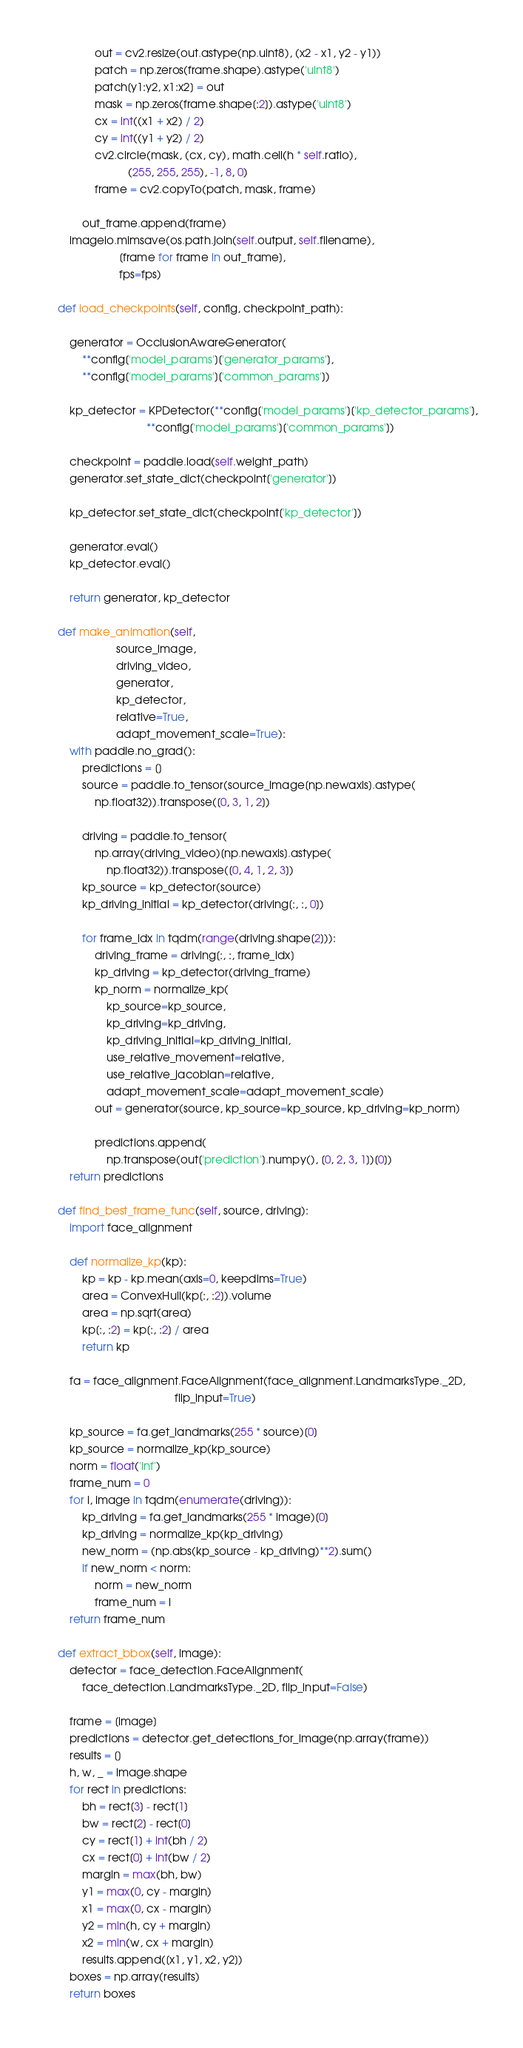Convert code to text. <code><loc_0><loc_0><loc_500><loc_500><_Python_>                out = cv2.resize(out.astype(np.uint8), (x2 - x1, y2 - y1))
                patch = np.zeros(frame.shape).astype('uint8')
                patch[y1:y2, x1:x2] = out
                mask = np.zeros(frame.shape[:2]).astype('uint8')
                cx = int((x1 + x2) / 2)
                cy = int((y1 + y2) / 2)
                cv2.circle(mask, (cx, cy), math.ceil(h * self.ratio),
                           (255, 255, 255), -1, 8, 0)
                frame = cv2.copyTo(patch, mask, frame)

            out_frame.append(frame)
        imageio.mimsave(os.path.join(self.output, self.filename),
                        [frame for frame in out_frame],
                        fps=fps)

    def load_checkpoints(self, config, checkpoint_path):

        generator = OcclusionAwareGenerator(
            **config['model_params']['generator_params'],
            **config['model_params']['common_params'])

        kp_detector = KPDetector(**config['model_params']['kp_detector_params'],
                                 **config['model_params']['common_params'])

        checkpoint = paddle.load(self.weight_path)
        generator.set_state_dict(checkpoint['generator'])

        kp_detector.set_state_dict(checkpoint['kp_detector'])

        generator.eval()
        kp_detector.eval()

        return generator, kp_detector

    def make_animation(self,
                       source_image,
                       driving_video,
                       generator,
                       kp_detector,
                       relative=True,
                       adapt_movement_scale=True):
        with paddle.no_grad():
            predictions = []
            source = paddle.to_tensor(source_image[np.newaxis].astype(
                np.float32)).transpose([0, 3, 1, 2])

            driving = paddle.to_tensor(
                np.array(driving_video)[np.newaxis].astype(
                    np.float32)).transpose([0, 4, 1, 2, 3])
            kp_source = kp_detector(source)
            kp_driving_initial = kp_detector(driving[:, :, 0])

            for frame_idx in tqdm(range(driving.shape[2])):
                driving_frame = driving[:, :, frame_idx]
                kp_driving = kp_detector(driving_frame)
                kp_norm = normalize_kp(
                    kp_source=kp_source,
                    kp_driving=kp_driving,
                    kp_driving_initial=kp_driving_initial,
                    use_relative_movement=relative,
                    use_relative_jacobian=relative,
                    adapt_movement_scale=adapt_movement_scale)
                out = generator(source, kp_source=kp_source, kp_driving=kp_norm)

                predictions.append(
                    np.transpose(out['prediction'].numpy(), [0, 2, 3, 1])[0])
        return predictions

    def find_best_frame_func(self, source, driving):
        import face_alignment

        def normalize_kp(kp):
            kp = kp - kp.mean(axis=0, keepdims=True)
            area = ConvexHull(kp[:, :2]).volume
            area = np.sqrt(area)
            kp[:, :2] = kp[:, :2] / area
            return kp

        fa = face_alignment.FaceAlignment(face_alignment.LandmarksType._2D,
                                          flip_input=True)

        kp_source = fa.get_landmarks(255 * source)[0]
        kp_source = normalize_kp(kp_source)
        norm = float('inf')
        frame_num = 0
        for i, image in tqdm(enumerate(driving)):
            kp_driving = fa.get_landmarks(255 * image)[0]
            kp_driving = normalize_kp(kp_driving)
            new_norm = (np.abs(kp_source - kp_driving)**2).sum()
            if new_norm < norm:
                norm = new_norm
                frame_num = i
        return frame_num

    def extract_bbox(self, image):
        detector = face_detection.FaceAlignment(
            face_detection.LandmarksType._2D, flip_input=False)

        frame = [image]
        predictions = detector.get_detections_for_image(np.array(frame))
        results = []
        h, w, _ = image.shape
        for rect in predictions:
            bh = rect[3] - rect[1]
            bw = rect[2] - rect[0]
            cy = rect[1] + int(bh / 2)
            cx = rect[0] + int(bw / 2)
            margin = max(bh, bw)
            y1 = max(0, cy - margin)
            x1 = max(0, cx - margin)
            y2 = min(h, cy + margin)
            x2 = min(w, cx + margin)
            results.append([x1, y1, x2, y2])
        boxes = np.array(results)
        return boxes
</code> 